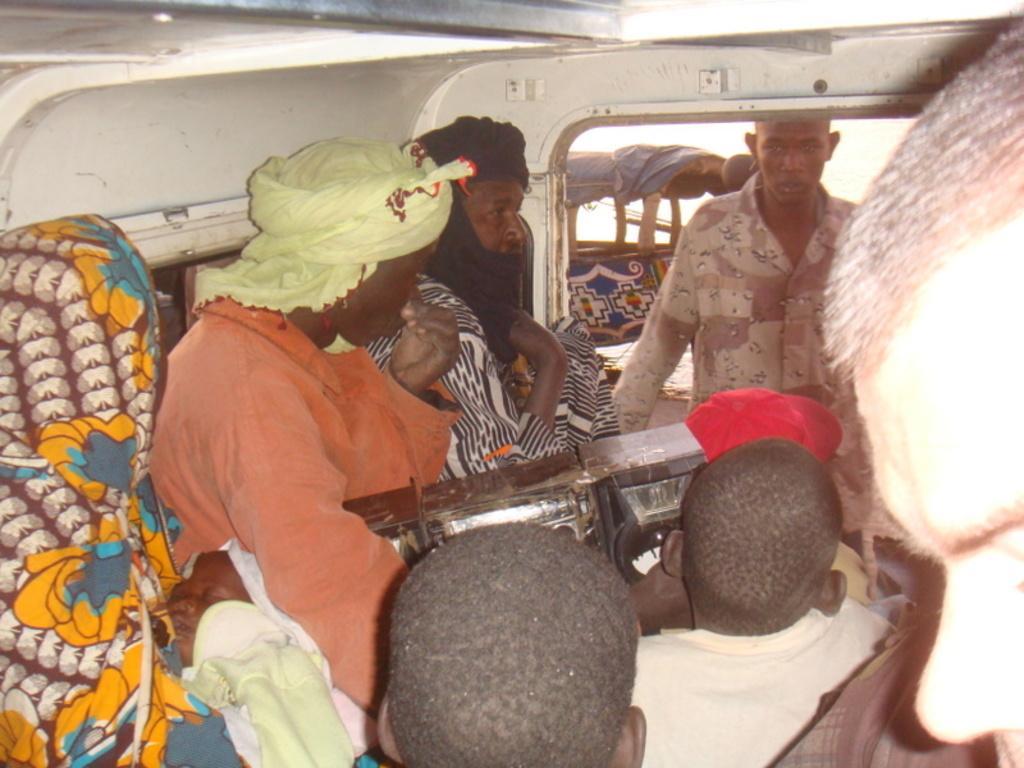Please provide a concise description of this image. This is the picture of a vehicle. In this image there are group of people sitting and there is a person with orange color shirt is holding the object. 